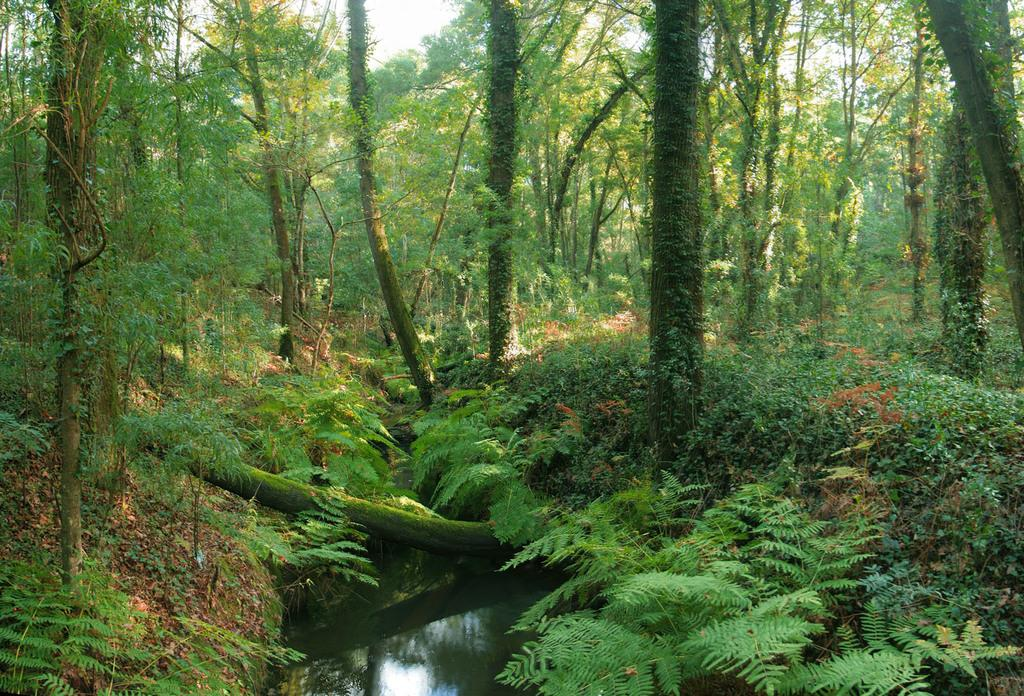What is visible in the image? Water is visible in the image. What is located near the water? Plants and trees are located near the water. How are the plants and trees positioned in relation to the water? The plants and trees are surrounding the water. What type of wristwatch can be seen on the tree in the image? There is no wristwatch present on the tree in the image. 